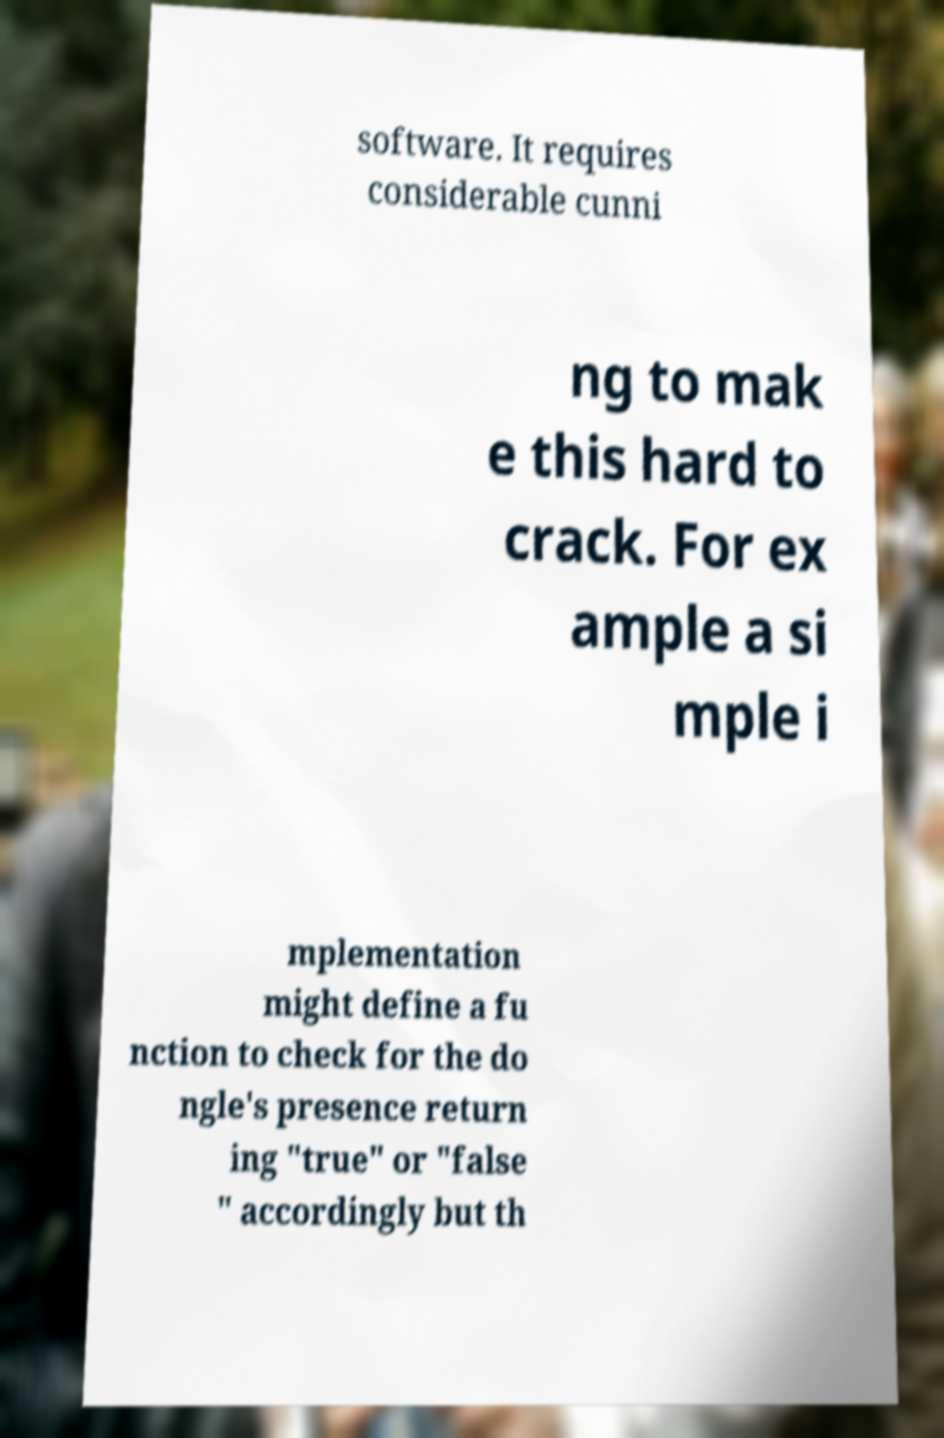I need the written content from this picture converted into text. Can you do that? software. It requires considerable cunni ng to mak e this hard to crack. For ex ample a si mple i mplementation might define a fu nction to check for the do ngle's presence return ing "true" or "false " accordingly but th 